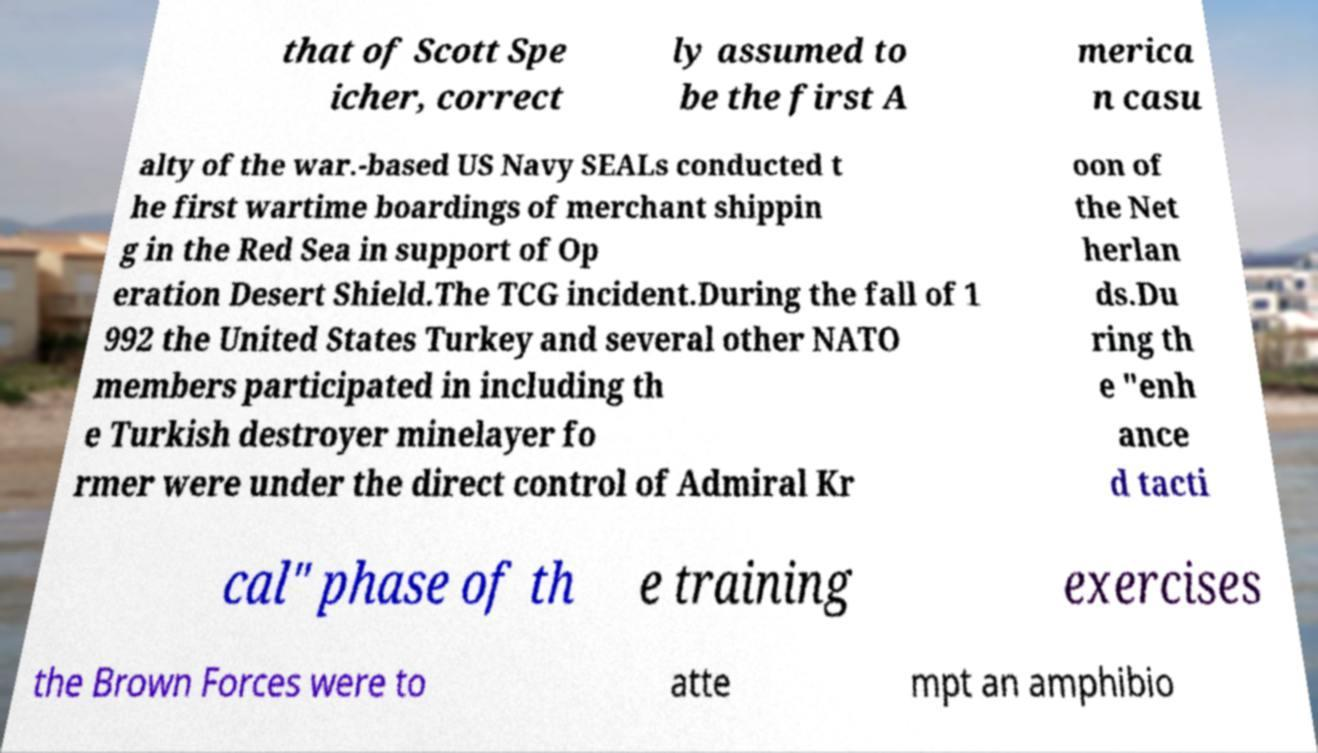For documentation purposes, I need the text within this image transcribed. Could you provide that? that of Scott Spe icher, correct ly assumed to be the first A merica n casu alty of the war.-based US Navy SEALs conducted t he first wartime boardings of merchant shippin g in the Red Sea in support of Op eration Desert Shield.The TCG incident.During the fall of 1 992 the United States Turkey and several other NATO members participated in including th e Turkish destroyer minelayer fo rmer were under the direct control of Admiral Kr oon of the Net herlan ds.Du ring th e "enh ance d tacti cal" phase of th e training exercises the Brown Forces were to atte mpt an amphibio 